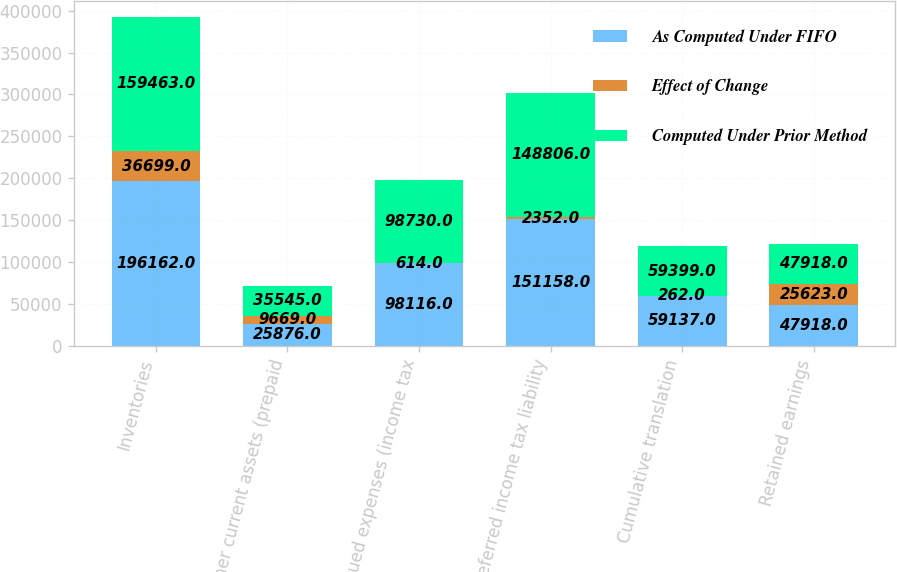<chart> <loc_0><loc_0><loc_500><loc_500><stacked_bar_chart><ecel><fcel>Inventories<fcel>Other current assets (prepaid<fcel>Accrued expenses (income tax<fcel>Deferred income tax liability<fcel>Cumulative translation<fcel>Retained earnings<nl><fcel>As Computed Under FIFO<fcel>196162<fcel>25876<fcel>98116<fcel>151158<fcel>59137<fcel>47918<nl><fcel>Effect of Change<fcel>36699<fcel>9669<fcel>614<fcel>2352<fcel>262<fcel>25623<nl><fcel>Computed Under Prior Method<fcel>159463<fcel>35545<fcel>98730<fcel>148806<fcel>59399<fcel>47918<nl></chart> 